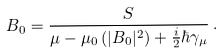Convert formula to latex. <formula><loc_0><loc_0><loc_500><loc_500>B _ { 0 } = \frac { S } { \mu - \mu _ { 0 } \left ( | B _ { 0 } | ^ { 2 } \right ) + \frac { i } { 2 } \hbar { \gamma } _ { \mu } } \, .</formula> 